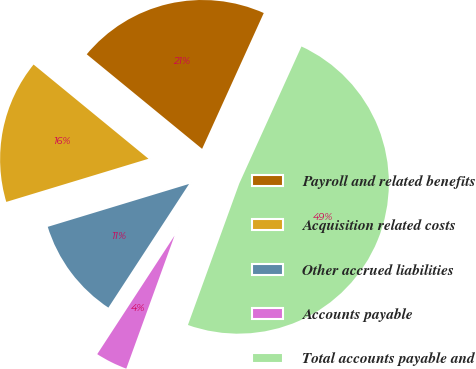Convert chart to OTSL. <chart><loc_0><loc_0><loc_500><loc_500><pie_chart><fcel>Payroll and related benefits<fcel>Acquisition related costs<fcel>Other accrued liabilities<fcel>Accounts payable<fcel>Total accounts payable and<nl><fcel>20.85%<fcel>15.62%<fcel>11.11%<fcel>3.66%<fcel>48.76%<nl></chart> 